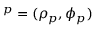Convert formula to latex. <formula><loc_0><loc_0><loc_500><loc_500>{ \ v O } ^ { p } = ( \rho _ { p } , \phi _ { p } )</formula> 